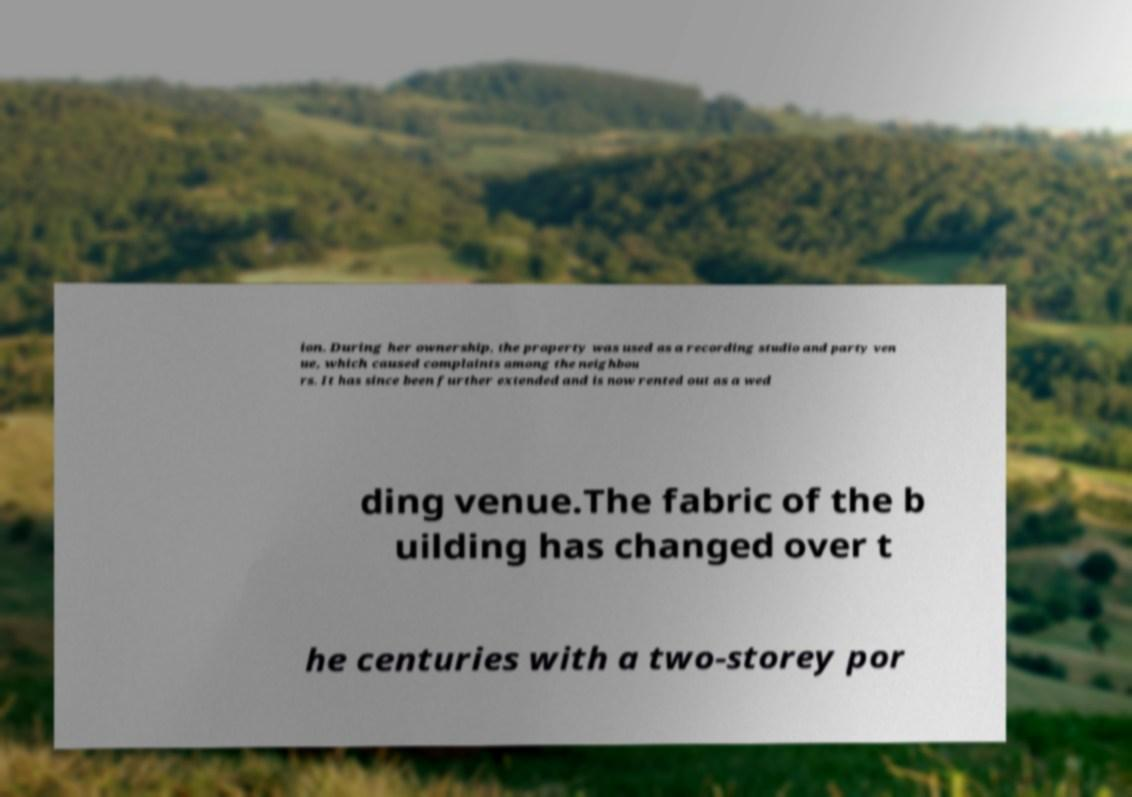There's text embedded in this image that I need extracted. Can you transcribe it verbatim? ion. During her ownership, the property was used as a recording studio and party ven ue, which caused complaints among the neighbou rs. It has since been further extended and is now rented out as a wed ding venue.The fabric of the b uilding has changed over t he centuries with a two-storey por 